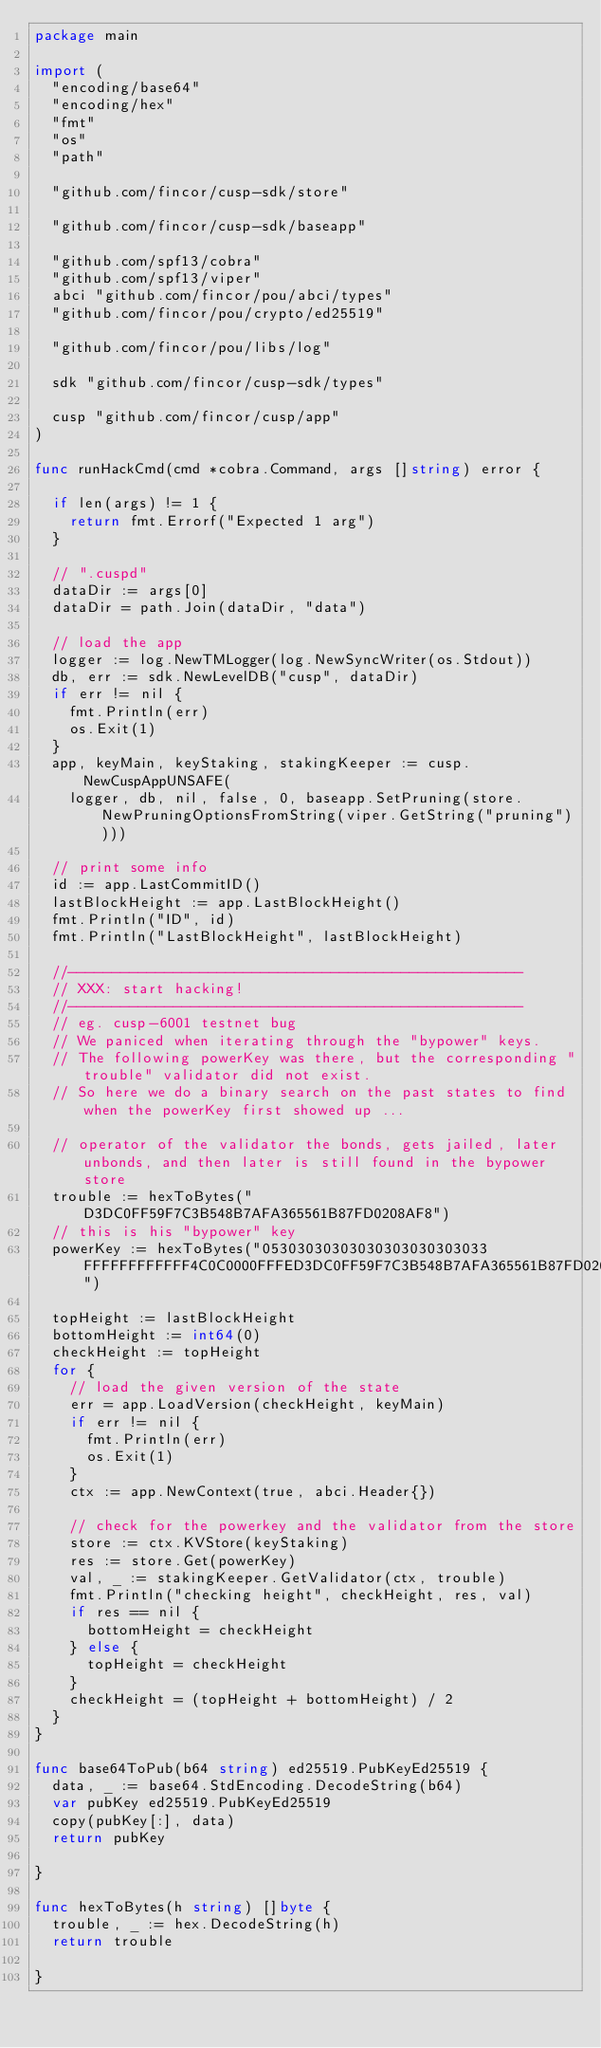<code> <loc_0><loc_0><loc_500><loc_500><_Go_>package main

import (
	"encoding/base64"
	"encoding/hex"
	"fmt"
	"os"
	"path"

	"github.com/fincor/cusp-sdk/store"

	"github.com/fincor/cusp-sdk/baseapp"

	"github.com/spf13/cobra"
	"github.com/spf13/viper"
	abci "github.com/fincor/pou/abci/types"
	"github.com/fincor/pou/crypto/ed25519"

	"github.com/fincor/pou/libs/log"

	sdk "github.com/fincor/cusp-sdk/types"

	cusp "github.com/fincor/cusp/app"
)

func runHackCmd(cmd *cobra.Command, args []string) error {

	if len(args) != 1 {
		return fmt.Errorf("Expected 1 arg")
	}

	// ".cuspd"
	dataDir := args[0]
	dataDir = path.Join(dataDir, "data")

	// load the app
	logger := log.NewTMLogger(log.NewSyncWriter(os.Stdout))
	db, err := sdk.NewLevelDB("cusp", dataDir)
	if err != nil {
		fmt.Println(err)
		os.Exit(1)
	}
	app, keyMain, keyStaking, stakingKeeper := cusp.NewCuspAppUNSAFE(
		logger, db, nil, false, 0, baseapp.SetPruning(store.NewPruningOptionsFromString(viper.GetString("pruning"))))

	// print some info
	id := app.LastCommitID()
	lastBlockHeight := app.LastBlockHeight()
	fmt.Println("ID", id)
	fmt.Println("LastBlockHeight", lastBlockHeight)

	//----------------------------------------------------
	// XXX: start hacking!
	//----------------------------------------------------
	// eg. cusp-6001 testnet bug
	// We paniced when iterating through the "bypower" keys.
	// The following powerKey was there, but the corresponding "trouble" validator did not exist.
	// So here we do a binary search on the past states to find when the powerKey first showed up ...

	// operator of the validator the bonds, gets jailed, later unbonds, and then later is still found in the bypower store
	trouble := hexToBytes("D3DC0FF59F7C3B548B7AFA365561B87FD0208AF8")
	// this is his "bypower" key
	powerKey := hexToBytes("05303030303030303030303033FFFFFFFFFFFF4C0C0000FFFED3DC0FF59F7C3B548B7AFA365561B87FD0208AF8")

	topHeight := lastBlockHeight
	bottomHeight := int64(0)
	checkHeight := topHeight
	for {
		// load the given version of the state
		err = app.LoadVersion(checkHeight, keyMain)
		if err != nil {
			fmt.Println(err)
			os.Exit(1)
		}
		ctx := app.NewContext(true, abci.Header{})

		// check for the powerkey and the validator from the store
		store := ctx.KVStore(keyStaking)
		res := store.Get(powerKey)
		val, _ := stakingKeeper.GetValidator(ctx, trouble)
		fmt.Println("checking height", checkHeight, res, val)
		if res == nil {
			bottomHeight = checkHeight
		} else {
			topHeight = checkHeight
		}
		checkHeight = (topHeight + bottomHeight) / 2
	}
}

func base64ToPub(b64 string) ed25519.PubKeyEd25519 {
	data, _ := base64.StdEncoding.DecodeString(b64)
	var pubKey ed25519.PubKeyEd25519
	copy(pubKey[:], data)
	return pubKey

}

func hexToBytes(h string) []byte {
	trouble, _ := hex.DecodeString(h)
	return trouble

}
</code> 